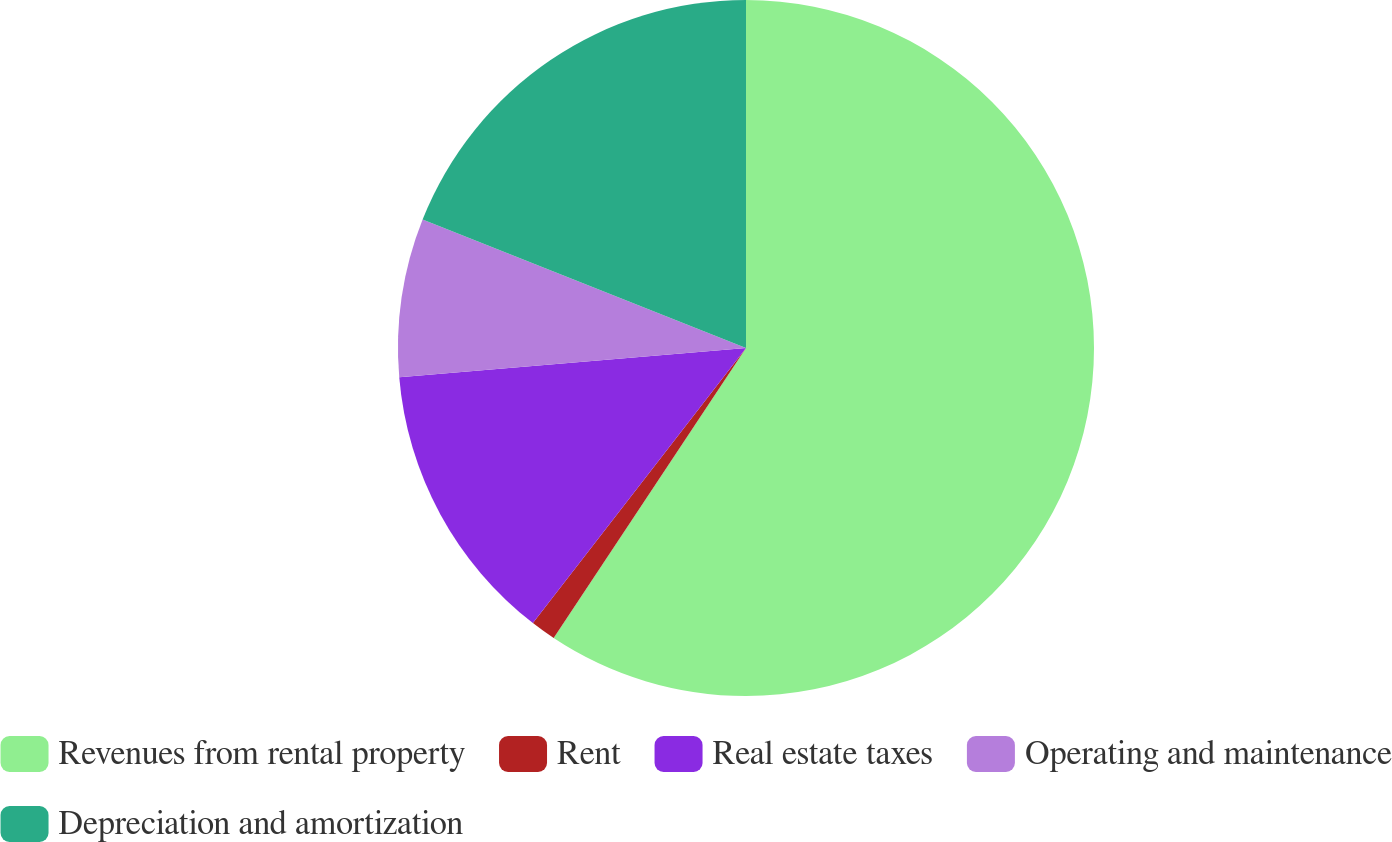Convert chart. <chart><loc_0><loc_0><loc_500><loc_500><pie_chart><fcel>Revenues from rental property<fcel>Rent<fcel>Real estate taxes<fcel>Operating and maintenance<fcel>Depreciation and amortization<nl><fcel>59.32%<fcel>1.17%<fcel>13.17%<fcel>7.36%<fcel>18.98%<nl></chart> 